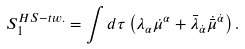Convert formula to latex. <formula><loc_0><loc_0><loc_500><loc_500>S _ { 1 } ^ { H S - t w . } = \int d \tau \left ( \lambda _ { \alpha } \dot { \mu } ^ { \alpha } + \bar { \lambda } _ { \dot { \alpha } } \dot { \bar { \mu } } ^ { \dot { \alpha } } \right ) .</formula> 